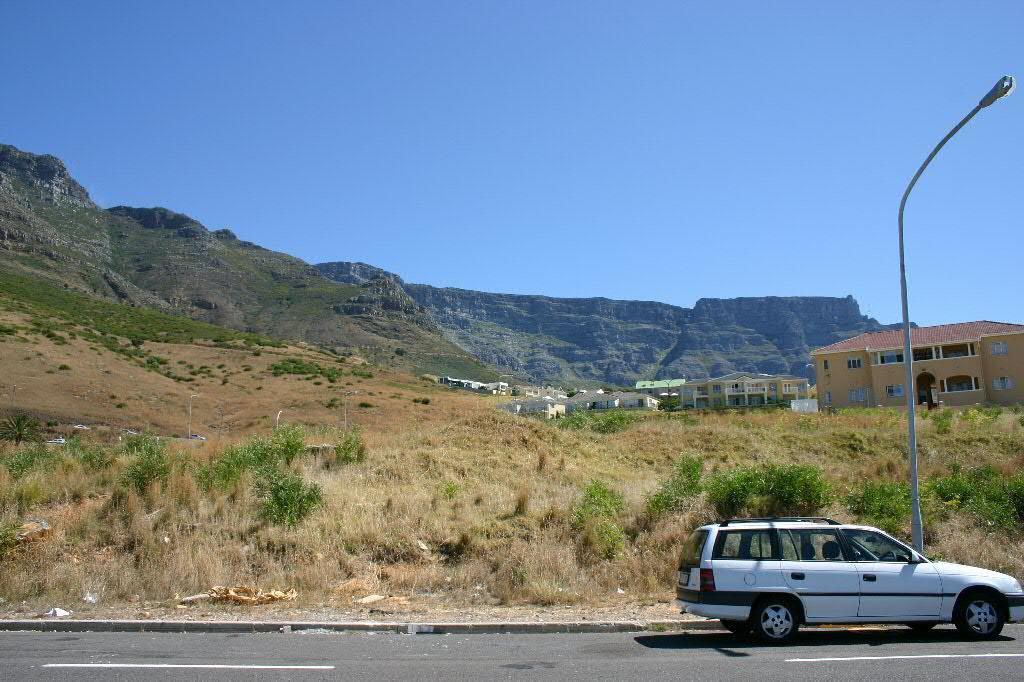What is the main feature of the image? There is a road in the image. What type of vehicle can be seen on the road? There is a white-colored vehicle on the road. What natural elements are present in the image? There are trees and a mountain in the image. What man-made structures can be seen in the image? There are buildings and a pole in the image. What part of the natural environment is visible in the background? The sky is visible in the background of the image. How many cribs can be seen in the image? There is no mention of a crib in the image, so it cannot be determined if any are present. 